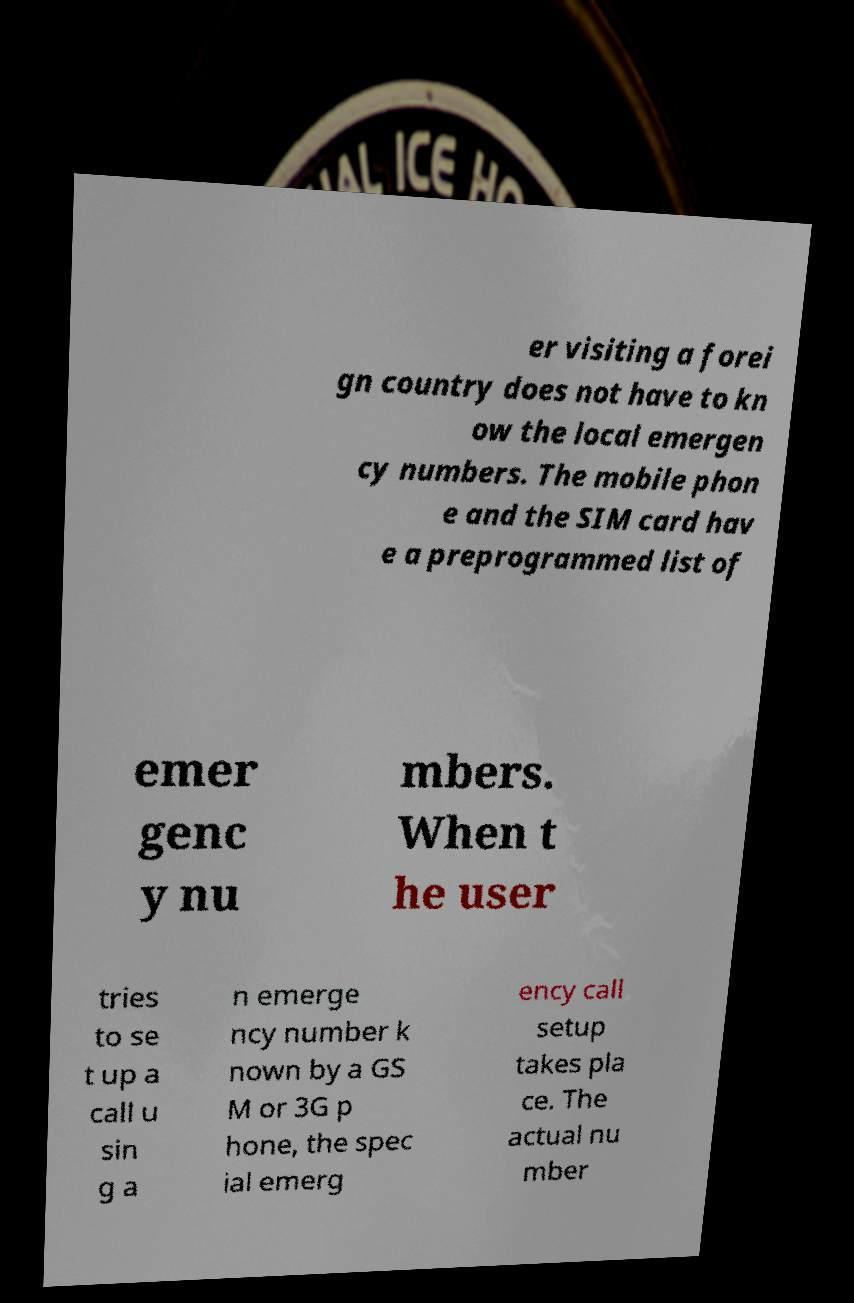Can you read and provide the text displayed in the image?This photo seems to have some interesting text. Can you extract and type it out for me? er visiting a forei gn country does not have to kn ow the local emergen cy numbers. The mobile phon e and the SIM card hav e a preprogrammed list of emer genc y nu mbers. When t he user tries to se t up a call u sin g a n emerge ncy number k nown by a GS M or 3G p hone, the spec ial emerg ency call setup takes pla ce. The actual nu mber 